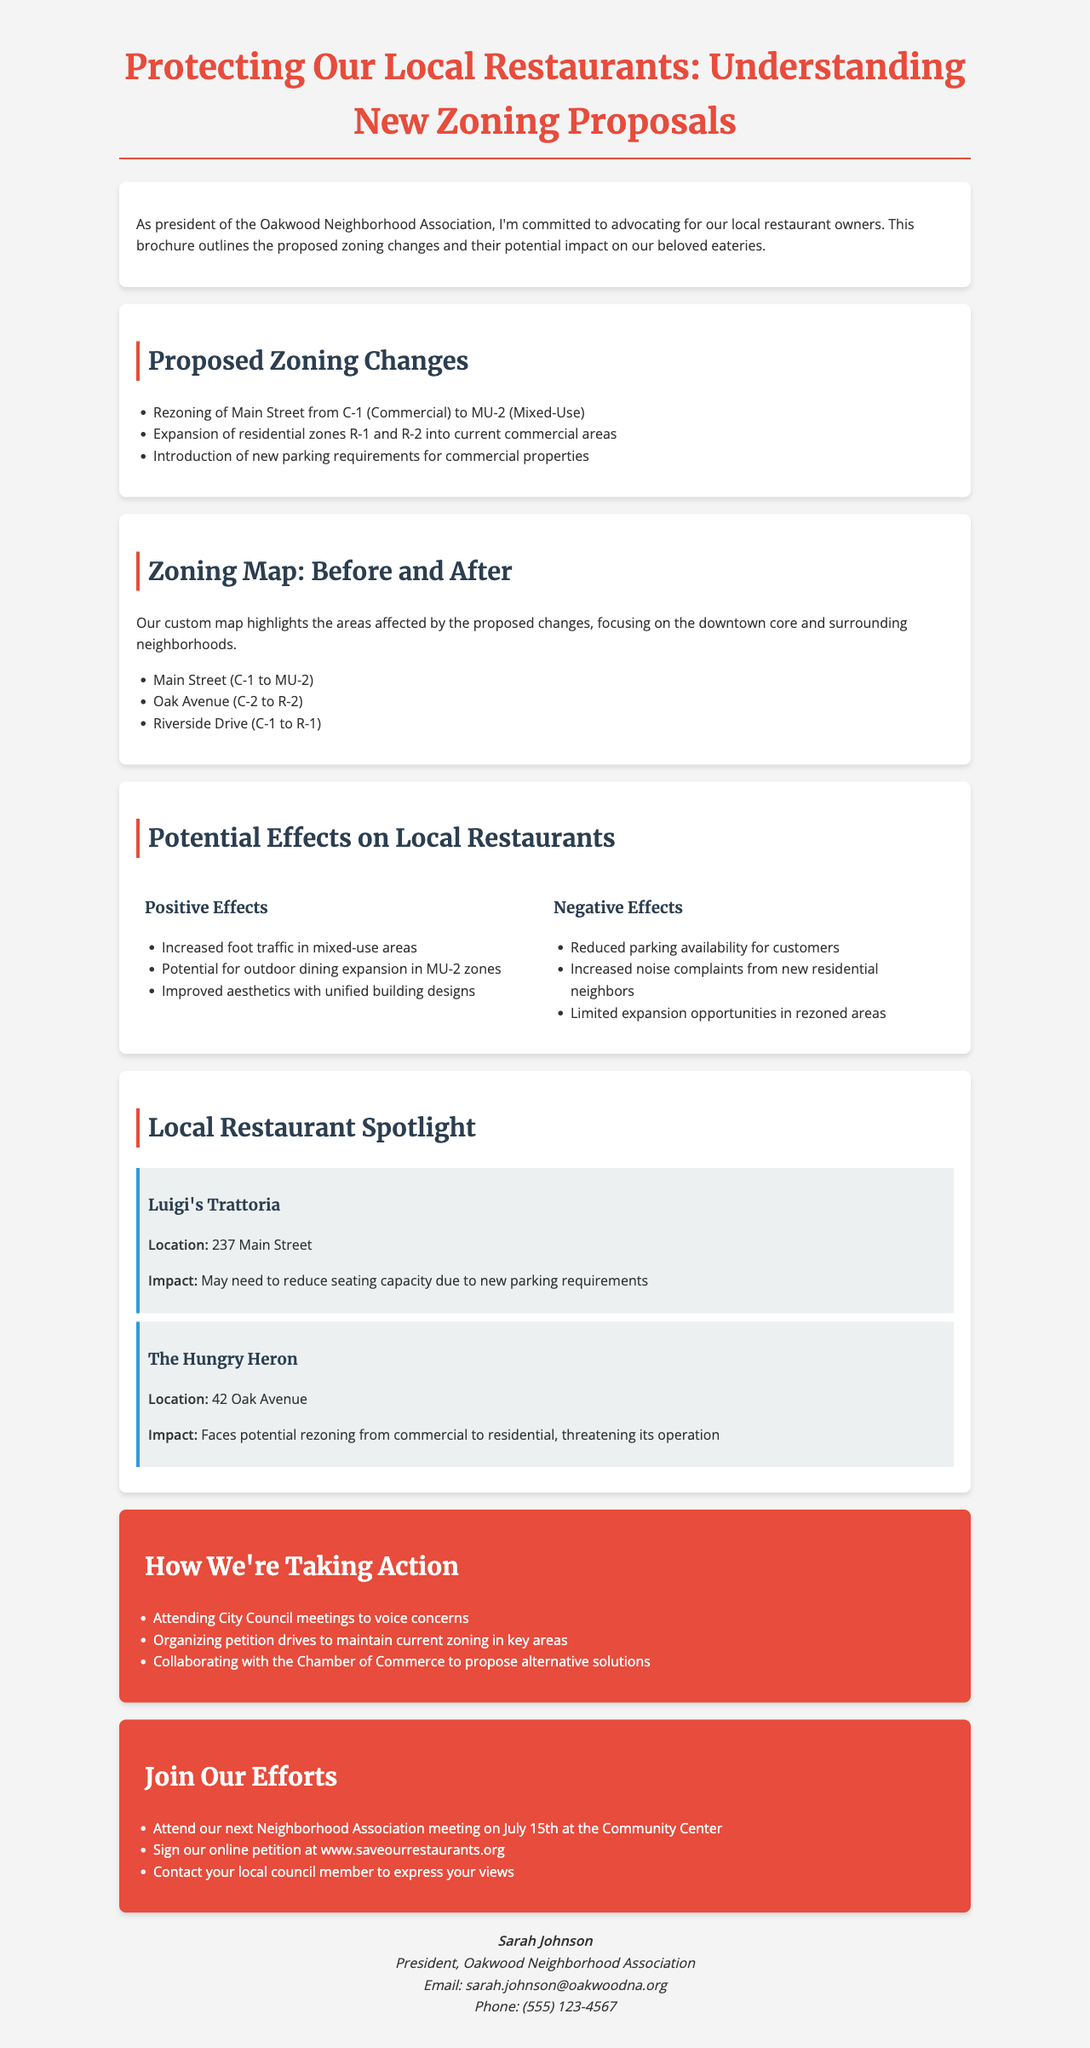What is the title of the brochure? The title of the brochure is prominently displayed at the top of the document.
Answer: Protecting Our Local Restaurants: Understanding New Zoning Proposals What zoning change is proposed for Main Street? The document specifies the proposed change for Main Street under the zoning overview section.
Answer: C-1 to MU-2 Which restaurant may need to reduce seating capacity? The case study section highlights the impact on specific local restaurants.
Answer: Luigi's Trattoria What is one positive effect of the zoning changes? The impact analysis section lists both positive and negative effects.
Answer: Increased foot traffic in mixed-use areas How are community members encouraged to get involved? The get involved section outlines ways for the community to take action regarding the zoning proposals.
Answer: Attend our next Neighborhood Association meeting What negative effect might arise from the new residential neighbors? The impact analysis section discusses various potential negative outcomes from the zoning changes.
Answer: Increased noise complaints What is one step mentioned in the action plan? The action plan section details the steps being taken to address the zoning proposals.
Answer: Attending City Council meetings to voice concerns Who is the contact person for this brochure? The contact info section provides details about the person to reach out to for more information.
Answer: Sarah Johnson What is the phone number provided for inquiries? The contact info section includes a phone number for further communication.
Answer: (555) 123-4567 